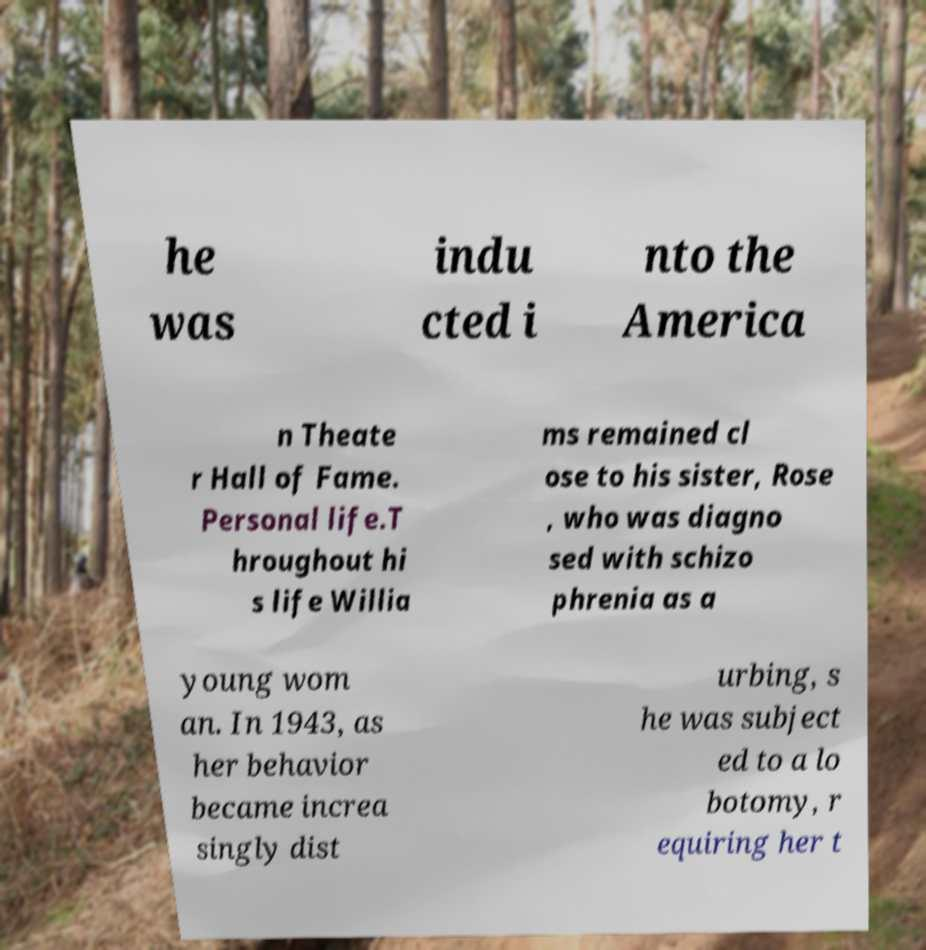Can you accurately transcribe the text from the provided image for me? he was indu cted i nto the America n Theate r Hall of Fame. Personal life.T hroughout hi s life Willia ms remained cl ose to his sister, Rose , who was diagno sed with schizo phrenia as a young wom an. In 1943, as her behavior became increa singly dist urbing, s he was subject ed to a lo botomy, r equiring her t 